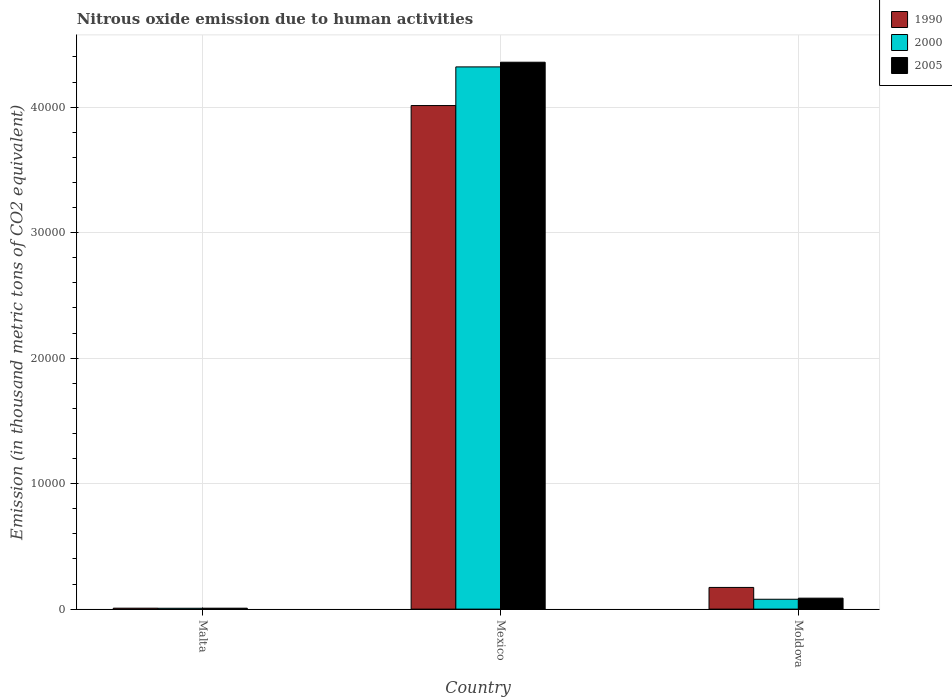How many bars are there on the 3rd tick from the left?
Give a very brief answer. 3. How many bars are there on the 3rd tick from the right?
Keep it short and to the point. 3. What is the label of the 3rd group of bars from the left?
Provide a short and direct response. Moldova. In how many cases, is the number of bars for a given country not equal to the number of legend labels?
Offer a terse response. 0. What is the amount of nitrous oxide emitted in 2000 in Moldova?
Make the answer very short. 785. Across all countries, what is the maximum amount of nitrous oxide emitted in 2005?
Provide a succinct answer. 4.36e+04. Across all countries, what is the minimum amount of nitrous oxide emitted in 2000?
Your answer should be very brief. 67.7. In which country was the amount of nitrous oxide emitted in 2005 maximum?
Provide a short and direct response. Mexico. In which country was the amount of nitrous oxide emitted in 1990 minimum?
Offer a terse response. Malta. What is the total amount of nitrous oxide emitted in 1990 in the graph?
Provide a succinct answer. 4.19e+04. What is the difference between the amount of nitrous oxide emitted in 2000 in Malta and that in Mexico?
Make the answer very short. -4.31e+04. What is the difference between the amount of nitrous oxide emitted in 1990 in Mexico and the amount of nitrous oxide emitted in 2000 in Moldova?
Keep it short and to the point. 3.93e+04. What is the average amount of nitrous oxide emitted in 2000 per country?
Provide a short and direct response. 1.47e+04. What is the difference between the amount of nitrous oxide emitted of/in 2005 and amount of nitrous oxide emitted of/in 1990 in Malta?
Offer a terse response. -1.1. What is the ratio of the amount of nitrous oxide emitted in 2000 in Malta to that in Moldova?
Make the answer very short. 0.09. What is the difference between the highest and the second highest amount of nitrous oxide emitted in 1990?
Offer a very short reply. -3.84e+04. What is the difference between the highest and the lowest amount of nitrous oxide emitted in 2005?
Offer a very short reply. 4.35e+04. Is the sum of the amount of nitrous oxide emitted in 1990 in Malta and Mexico greater than the maximum amount of nitrous oxide emitted in 2005 across all countries?
Keep it short and to the point. No. What does the 1st bar from the left in Mexico represents?
Ensure brevity in your answer.  1990. What does the 2nd bar from the right in Moldova represents?
Make the answer very short. 2000. Is it the case that in every country, the sum of the amount of nitrous oxide emitted in 2000 and amount of nitrous oxide emitted in 1990 is greater than the amount of nitrous oxide emitted in 2005?
Your answer should be very brief. Yes. How many bars are there?
Give a very brief answer. 9. Are all the bars in the graph horizontal?
Your answer should be very brief. No. What is the difference between two consecutive major ticks on the Y-axis?
Give a very brief answer. 10000. Are the values on the major ticks of Y-axis written in scientific E-notation?
Give a very brief answer. No. Does the graph contain any zero values?
Provide a short and direct response. No. Where does the legend appear in the graph?
Make the answer very short. Top right. What is the title of the graph?
Make the answer very short. Nitrous oxide emission due to human activities. What is the label or title of the X-axis?
Offer a very short reply. Country. What is the label or title of the Y-axis?
Your answer should be compact. Emission (in thousand metric tons of CO2 equivalent). What is the Emission (in thousand metric tons of CO2 equivalent) of 1990 in Malta?
Keep it short and to the point. 74.4. What is the Emission (in thousand metric tons of CO2 equivalent) in 2000 in Malta?
Give a very brief answer. 67.7. What is the Emission (in thousand metric tons of CO2 equivalent) of 2005 in Malta?
Offer a terse response. 73.3. What is the Emission (in thousand metric tons of CO2 equivalent) of 1990 in Mexico?
Your answer should be compact. 4.01e+04. What is the Emission (in thousand metric tons of CO2 equivalent) in 2000 in Mexico?
Provide a succinct answer. 4.32e+04. What is the Emission (in thousand metric tons of CO2 equivalent) of 2005 in Mexico?
Your answer should be very brief. 4.36e+04. What is the Emission (in thousand metric tons of CO2 equivalent) in 1990 in Moldova?
Keep it short and to the point. 1728.3. What is the Emission (in thousand metric tons of CO2 equivalent) in 2000 in Moldova?
Make the answer very short. 785. What is the Emission (in thousand metric tons of CO2 equivalent) of 2005 in Moldova?
Provide a short and direct response. 872.9. Across all countries, what is the maximum Emission (in thousand metric tons of CO2 equivalent) in 1990?
Your answer should be compact. 4.01e+04. Across all countries, what is the maximum Emission (in thousand metric tons of CO2 equivalent) in 2000?
Keep it short and to the point. 4.32e+04. Across all countries, what is the maximum Emission (in thousand metric tons of CO2 equivalent) of 2005?
Your answer should be compact. 4.36e+04. Across all countries, what is the minimum Emission (in thousand metric tons of CO2 equivalent) of 1990?
Offer a very short reply. 74.4. Across all countries, what is the minimum Emission (in thousand metric tons of CO2 equivalent) in 2000?
Make the answer very short. 67.7. Across all countries, what is the minimum Emission (in thousand metric tons of CO2 equivalent) in 2005?
Keep it short and to the point. 73.3. What is the total Emission (in thousand metric tons of CO2 equivalent) in 1990 in the graph?
Your answer should be compact. 4.19e+04. What is the total Emission (in thousand metric tons of CO2 equivalent) of 2000 in the graph?
Your answer should be very brief. 4.41e+04. What is the total Emission (in thousand metric tons of CO2 equivalent) in 2005 in the graph?
Provide a short and direct response. 4.45e+04. What is the difference between the Emission (in thousand metric tons of CO2 equivalent) in 1990 in Malta and that in Mexico?
Offer a very short reply. -4.01e+04. What is the difference between the Emission (in thousand metric tons of CO2 equivalent) in 2000 in Malta and that in Mexico?
Your response must be concise. -4.31e+04. What is the difference between the Emission (in thousand metric tons of CO2 equivalent) of 2005 in Malta and that in Mexico?
Ensure brevity in your answer.  -4.35e+04. What is the difference between the Emission (in thousand metric tons of CO2 equivalent) of 1990 in Malta and that in Moldova?
Give a very brief answer. -1653.9. What is the difference between the Emission (in thousand metric tons of CO2 equivalent) in 2000 in Malta and that in Moldova?
Offer a terse response. -717.3. What is the difference between the Emission (in thousand metric tons of CO2 equivalent) in 2005 in Malta and that in Moldova?
Provide a short and direct response. -799.6. What is the difference between the Emission (in thousand metric tons of CO2 equivalent) in 1990 in Mexico and that in Moldova?
Provide a succinct answer. 3.84e+04. What is the difference between the Emission (in thousand metric tons of CO2 equivalent) of 2000 in Mexico and that in Moldova?
Offer a terse response. 4.24e+04. What is the difference between the Emission (in thousand metric tons of CO2 equivalent) of 2005 in Mexico and that in Moldova?
Provide a succinct answer. 4.27e+04. What is the difference between the Emission (in thousand metric tons of CO2 equivalent) in 1990 in Malta and the Emission (in thousand metric tons of CO2 equivalent) in 2000 in Mexico?
Your response must be concise. -4.31e+04. What is the difference between the Emission (in thousand metric tons of CO2 equivalent) of 1990 in Malta and the Emission (in thousand metric tons of CO2 equivalent) of 2005 in Mexico?
Offer a terse response. -4.35e+04. What is the difference between the Emission (in thousand metric tons of CO2 equivalent) of 2000 in Malta and the Emission (in thousand metric tons of CO2 equivalent) of 2005 in Mexico?
Provide a short and direct response. -4.35e+04. What is the difference between the Emission (in thousand metric tons of CO2 equivalent) of 1990 in Malta and the Emission (in thousand metric tons of CO2 equivalent) of 2000 in Moldova?
Provide a short and direct response. -710.6. What is the difference between the Emission (in thousand metric tons of CO2 equivalent) in 1990 in Malta and the Emission (in thousand metric tons of CO2 equivalent) in 2005 in Moldova?
Your answer should be very brief. -798.5. What is the difference between the Emission (in thousand metric tons of CO2 equivalent) in 2000 in Malta and the Emission (in thousand metric tons of CO2 equivalent) in 2005 in Moldova?
Keep it short and to the point. -805.2. What is the difference between the Emission (in thousand metric tons of CO2 equivalent) of 1990 in Mexico and the Emission (in thousand metric tons of CO2 equivalent) of 2000 in Moldova?
Keep it short and to the point. 3.93e+04. What is the difference between the Emission (in thousand metric tons of CO2 equivalent) of 1990 in Mexico and the Emission (in thousand metric tons of CO2 equivalent) of 2005 in Moldova?
Your response must be concise. 3.93e+04. What is the difference between the Emission (in thousand metric tons of CO2 equivalent) in 2000 in Mexico and the Emission (in thousand metric tons of CO2 equivalent) in 2005 in Moldova?
Offer a terse response. 4.23e+04. What is the average Emission (in thousand metric tons of CO2 equivalent) of 1990 per country?
Ensure brevity in your answer.  1.40e+04. What is the average Emission (in thousand metric tons of CO2 equivalent) of 2000 per country?
Keep it short and to the point. 1.47e+04. What is the average Emission (in thousand metric tons of CO2 equivalent) in 2005 per country?
Give a very brief answer. 1.48e+04. What is the difference between the Emission (in thousand metric tons of CO2 equivalent) in 1990 and Emission (in thousand metric tons of CO2 equivalent) in 2005 in Malta?
Provide a short and direct response. 1.1. What is the difference between the Emission (in thousand metric tons of CO2 equivalent) of 1990 and Emission (in thousand metric tons of CO2 equivalent) of 2000 in Mexico?
Your response must be concise. -3080.7. What is the difference between the Emission (in thousand metric tons of CO2 equivalent) in 1990 and Emission (in thousand metric tons of CO2 equivalent) in 2005 in Mexico?
Keep it short and to the point. -3453. What is the difference between the Emission (in thousand metric tons of CO2 equivalent) in 2000 and Emission (in thousand metric tons of CO2 equivalent) in 2005 in Mexico?
Ensure brevity in your answer.  -372.3. What is the difference between the Emission (in thousand metric tons of CO2 equivalent) of 1990 and Emission (in thousand metric tons of CO2 equivalent) of 2000 in Moldova?
Keep it short and to the point. 943.3. What is the difference between the Emission (in thousand metric tons of CO2 equivalent) in 1990 and Emission (in thousand metric tons of CO2 equivalent) in 2005 in Moldova?
Provide a succinct answer. 855.4. What is the difference between the Emission (in thousand metric tons of CO2 equivalent) in 2000 and Emission (in thousand metric tons of CO2 equivalent) in 2005 in Moldova?
Your answer should be compact. -87.9. What is the ratio of the Emission (in thousand metric tons of CO2 equivalent) in 1990 in Malta to that in Mexico?
Offer a terse response. 0. What is the ratio of the Emission (in thousand metric tons of CO2 equivalent) of 2000 in Malta to that in Mexico?
Your answer should be compact. 0. What is the ratio of the Emission (in thousand metric tons of CO2 equivalent) of 2005 in Malta to that in Mexico?
Offer a very short reply. 0. What is the ratio of the Emission (in thousand metric tons of CO2 equivalent) in 1990 in Malta to that in Moldova?
Offer a terse response. 0.04. What is the ratio of the Emission (in thousand metric tons of CO2 equivalent) in 2000 in Malta to that in Moldova?
Offer a very short reply. 0.09. What is the ratio of the Emission (in thousand metric tons of CO2 equivalent) in 2005 in Malta to that in Moldova?
Your response must be concise. 0.08. What is the ratio of the Emission (in thousand metric tons of CO2 equivalent) in 1990 in Mexico to that in Moldova?
Keep it short and to the point. 23.22. What is the ratio of the Emission (in thousand metric tons of CO2 equivalent) of 2000 in Mexico to that in Moldova?
Provide a short and direct response. 55.05. What is the ratio of the Emission (in thousand metric tons of CO2 equivalent) of 2005 in Mexico to that in Moldova?
Your response must be concise. 49.93. What is the difference between the highest and the second highest Emission (in thousand metric tons of CO2 equivalent) of 1990?
Your response must be concise. 3.84e+04. What is the difference between the highest and the second highest Emission (in thousand metric tons of CO2 equivalent) of 2000?
Your answer should be compact. 4.24e+04. What is the difference between the highest and the second highest Emission (in thousand metric tons of CO2 equivalent) of 2005?
Give a very brief answer. 4.27e+04. What is the difference between the highest and the lowest Emission (in thousand metric tons of CO2 equivalent) in 1990?
Your answer should be very brief. 4.01e+04. What is the difference between the highest and the lowest Emission (in thousand metric tons of CO2 equivalent) in 2000?
Provide a succinct answer. 4.31e+04. What is the difference between the highest and the lowest Emission (in thousand metric tons of CO2 equivalent) of 2005?
Offer a very short reply. 4.35e+04. 